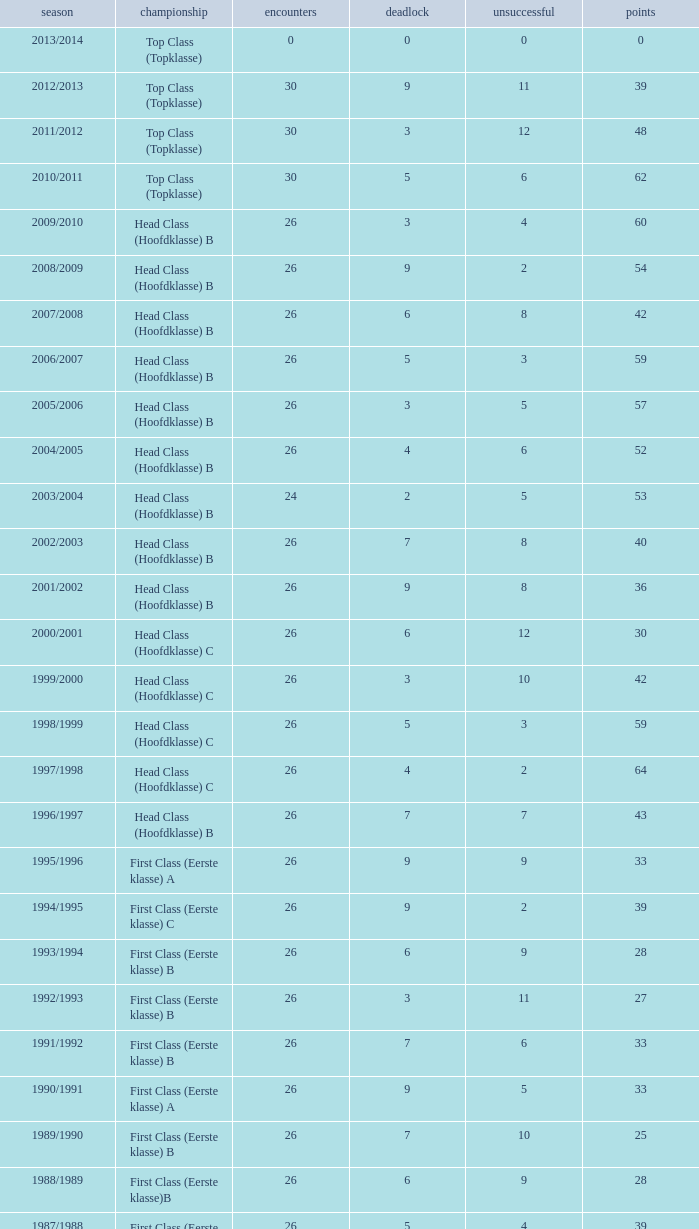What is the sum of the losses that a match score larger than 26, a points score of 62, and a draw greater than 5? None. 